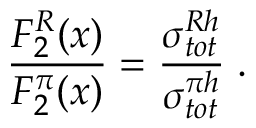Convert formula to latex. <formula><loc_0><loc_0><loc_500><loc_500>\frac { F _ { 2 } ^ { R } ( x ) } { F _ { 2 } ^ { \pi } ( x ) } = \frac { \sigma _ { t o t } ^ { R h } } { \sigma _ { t o t } ^ { \pi h } } \, .</formula> 